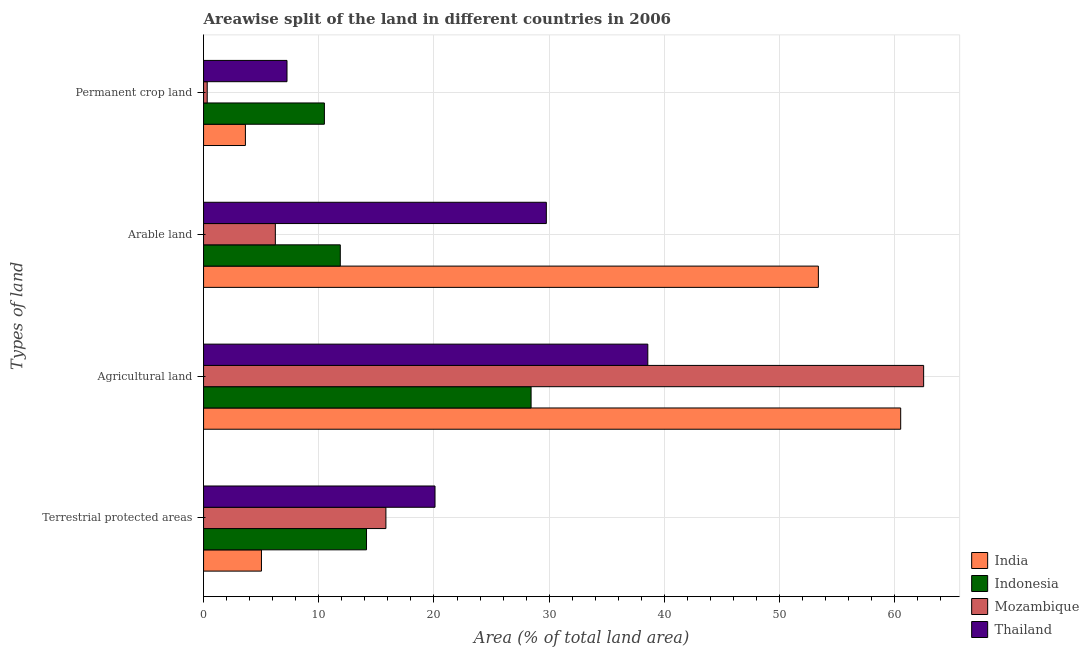How many different coloured bars are there?
Ensure brevity in your answer.  4. How many groups of bars are there?
Provide a short and direct response. 4. Are the number of bars per tick equal to the number of legend labels?
Give a very brief answer. Yes. How many bars are there on the 3rd tick from the bottom?
Provide a succinct answer. 4. What is the label of the 1st group of bars from the top?
Give a very brief answer. Permanent crop land. What is the percentage of area under permanent crop land in Mozambique?
Provide a short and direct response. 0.32. Across all countries, what is the maximum percentage of area under arable land?
Make the answer very short. 53.36. Across all countries, what is the minimum percentage of area under permanent crop land?
Ensure brevity in your answer.  0.32. In which country was the percentage of land under terrestrial protection maximum?
Your answer should be very brief. Thailand. In which country was the percentage of area under permanent crop land minimum?
Offer a terse response. Mozambique. What is the total percentage of area under permanent crop land in the graph?
Ensure brevity in your answer.  21.68. What is the difference between the percentage of area under agricultural land in India and that in Indonesia?
Give a very brief answer. 32.08. What is the difference between the percentage of land under terrestrial protection in Mozambique and the percentage of area under permanent crop land in India?
Ensure brevity in your answer.  12.19. What is the average percentage of area under permanent crop land per country?
Offer a very short reply. 5.42. What is the difference between the percentage of area under arable land and percentage of land under terrestrial protection in Indonesia?
Your response must be concise. -2.28. In how many countries, is the percentage of land under terrestrial protection greater than 30 %?
Your answer should be very brief. 0. What is the ratio of the percentage of land under terrestrial protection in India to that in Indonesia?
Ensure brevity in your answer.  0.36. Is the percentage of area under permanent crop land in Thailand less than that in Mozambique?
Provide a short and direct response. No. Is the difference between the percentage of area under arable land in Indonesia and Mozambique greater than the difference between the percentage of land under terrestrial protection in Indonesia and Mozambique?
Offer a terse response. Yes. What is the difference between the highest and the second highest percentage of area under agricultural land?
Provide a short and direct response. 1.99. What is the difference between the highest and the lowest percentage of area under arable land?
Offer a very short reply. 47.13. Is the sum of the percentage of area under arable land in Indonesia and India greater than the maximum percentage of area under agricultural land across all countries?
Give a very brief answer. Yes. What does the 2nd bar from the top in Permanent crop land represents?
Offer a very short reply. Mozambique. Are all the bars in the graph horizontal?
Ensure brevity in your answer.  Yes. What is the difference between two consecutive major ticks on the X-axis?
Keep it short and to the point. 10. Are the values on the major ticks of X-axis written in scientific E-notation?
Provide a succinct answer. No. Does the graph contain grids?
Your answer should be very brief. Yes. Where does the legend appear in the graph?
Offer a terse response. Bottom right. What is the title of the graph?
Give a very brief answer. Areawise split of the land in different countries in 2006. Does "Euro area" appear as one of the legend labels in the graph?
Provide a succinct answer. No. What is the label or title of the X-axis?
Keep it short and to the point. Area (% of total land area). What is the label or title of the Y-axis?
Your answer should be very brief. Types of land. What is the Area (% of total land area) in India in Terrestrial protected areas?
Your response must be concise. 5.03. What is the Area (% of total land area) in Indonesia in Terrestrial protected areas?
Keep it short and to the point. 14.14. What is the Area (% of total land area) of Mozambique in Terrestrial protected areas?
Give a very brief answer. 15.83. What is the Area (% of total land area) of Thailand in Terrestrial protected areas?
Provide a short and direct response. 20.09. What is the Area (% of total land area) of India in Agricultural land?
Offer a very short reply. 60.51. What is the Area (% of total land area) of Indonesia in Agricultural land?
Ensure brevity in your answer.  28.43. What is the Area (% of total land area) in Mozambique in Agricultural land?
Provide a succinct answer. 62.5. What is the Area (% of total land area) of Thailand in Agricultural land?
Your answer should be compact. 38.56. What is the Area (% of total land area) in India in Arable land?
Give a very brief answer. 53.36. What is the Area (% of total land area) in Indonesia in Arable land?
Offer a terse response. 11.87. What is the Area (% of total land area) in Mozambique in Arable land?
Your answer should be compact. 6.23. What is the Area (% of total land area) of Thailand in Arable land?
Give a very brief answer. 29.75. What is the Area (% of total land area) of India in Permanent crop land?
Provide a short and direct response. 3.63. What is the Area (% of total land area) of Indonesia in Permanent crop land?
Give a very brief answer. 10.49. What is the Area (% of total land area) in Mozambique in Permanent crop land?
Your answer should be very brief. 0.32. What is the Area (% of total land area) in Thailand in Permanent crop land?
Offer a terse response. 7.24. Across all Types of land, what is the maximum Area (% of total land area) of India?
Your answer should be compact. 60.51. Across all Types of land, what is the maximum Area (% of total land area) of Indonesia?
Your answer should be compact. 28.43. Across all Types of land, what is the maximum Area (% of total land area) in Mozambique?
Your response must be concise. 62.5. Across all Types of land, what is the maximum Area (% of total land area) of Thailand?
Offer a terse response. 38.56. Across all Types of land, what is the minimum Area (% of total land area) in India?
Your response must be concise. 3.63. Across all Types of land, what is the minimum Area (% of total land area) in Indonesia?
Your response must be concise. 10.49. Across all Types of land, what is the minimum Area (% of total land area) in Mozambique?
Your response must be concise. 0.32. Across all Types of land, what is the minimum Area (% of total land area) of Thailand?
Give a very brief answer. 7.24. What is the total Area (% of total land area) of India in the graph?
Your response must be concise. 122.53. What is the total Area (% of total land area) in Indonesia in the graph?
Your answer should be compact. 64.93. What is the total Area (% of total land area) of Mozambique in the graph?
Your response must be concise. 84.88. What is the total Area (% of total land area) of Thailand in the graph?
Provide a short and direct response. 95.64. What is the difference between the Area (% of total land area) of India in Terrestrial protected areas and that in Agricultural land?
Offer a very short reply. -55.48. What is the difference between the Area (% of total land area) of Indonesia in Terrestrial protected areas and that in Agricultural land?
Make the answer very short. -14.28. What is the difference between the Area (% of total land area) in Mozambique in Terrestrial protected areas and that in Agricultural land?
Give a very brief answer. -46.67. What is the difference between the Area (% of total land area) in Thailand in Terrestrial protected areas and that in Agricultural land?
Your response must be concise. -18.47. What is the difference between the Area (% of total land area) of India in Terrestrial protected areas and that in Arable land?
Your response must be concise. -48.34. What is the difference between the Area (% of total land area) in Indonesia in Terrestrial protected areas and that in Arable land?
Provide a short and direct response. 2.28. What is the difference between the Area (% of total land area) of Mozambique in Terrestrial protected areas and that in Arable land?
Your answer should be very brief. 9.6. What is the difference between the Area (% of total land area) of Thailand in Terrestrial protected areas and that in Arable land?
Offer a very short reply. -9.66. What is the difference between the Area (% of total land area) of India in Terrestrial protected areas and that in Permanent crop land?
Your response must be concise. 1.39. What is the difference between the Area (% of total land area) in Indonesia in Terrestrial protected areas and that in Permanent crop land?
Give a very brief answer. 3.66. What is the difference between the Area (% of total land area) of Mozambique in Terrestrial protected areas and that in Permanent crop land?
Your answer should be very brief. 15.51. What is the difference between the Area (% of total land area) of Thailand in Terrestrial protected areas and that in Permanent crop land?
Your answer should be compact. 12.85. What is the difference between the Area (% of total land area) of India in Agricultural land and that in Arable land?
Your response must be concise. 7.15. What is the difference between the Area (% of total land area) of Indonesia in Agricultural land and that in Arable land?
Offer a terse response. 16.56. What is the difference between the Area (% of total land area) of Mozambique in Agricultural land and that in Arable land?
Your answer should be very brief. 56.27. What is the difference between the Area (% of total land area) in Thailand in Agricultural land and that in Arable land?
Your answer should be compact. 8.81. What is the difference between the Area (% of total land area) in India in Agricultural land and that in Permanent crop land?
Ensure brevity in your answer.  56.88. What is the difference between the Area (% of total land area) of Indonesia in Agricultural land and that in Permanent crop land?
Keep it short and to the point. 17.94. What is the difference between the Area (% of total land area) of Mozambique in Agricultural land and that in Permanent crop land?
Your answer should be compact. 62.18. What is the difference between the Area (% of total land area) of Thailand in Agricultural land and that in Permanent crop land?
Keep it short and to the point. 31.32. What is the difference between the Area (% of total land area) in India in Arable land and that in Permanent crop land?
Your response must be concise. 49.73. What is the difference between the Area (% of total land area) of Indonesia in Arable land and that in Permanent crop land?
Your answer should be compact. 1.38. What is the difference between the Area (% of total land area) of Mozambique in Arable land and that in Permanent crop land?
Offer a terse response. 5.91. What is the difference between the Area (% of total land area) in Thailand in Arable land and that in Permanent crop land?
Give a very brief answer. 22.51. What is the difference between the Area (% of total land area) in India in Terrestrial protected areas and the Area (% of total land area) in Indonesia in Agricultural land?
Give a very brief answer. -23.4. What is the difference between the Area (% of total land area) in India in Terrestrial protected areas and the Area (% of total land area) in Mozambique in Agricultural land?
Your answer should be compact. -57.48. What is the difference between the Area (% of total land area) in India in Terrestrial protected areas and the Area (% of total land area) in Thailand in Agricultural land?
Offer a very short reply. -33.54. What is the difference between the Area (% of total land area) of Indonesia in Terrestrial protected areas and the Area (% of total land area) of Mozambique in Agricultural land?
Offer a very short reply. -48.36. What is the difference between the Area (% of total land area) of Indonesia in Terrestrial protected areas and the Area (% of total land area) of Thailand in Agricultural land?
Offer a very short reply. -24.42. What is the difference between the Area (% of total land area) in Mozambique in Terrestrial protected areas and the Area (% of total land area) in Thailand in Agricultural land?
Keep it short and to the point. -22.73. What is the difference between the Area (% of total land area) of India in Terrestrial protected areas and the Area (% of total land area) of Indonesia in Arable land?
Make the answer very short. -6.84. What is the difference between the Area (% of total land area) of India in Terrestrial protected areas and the Area (% of total land area) of Mozambique in Arable land?
Make the answer very short. -1.21. What is the difference between the Area (% of total land area) of India in Terrestrial protected areas and the Area (% of total land area) of Thailand in Arable land?
Offer a terse response. -24.73. What is the difference between the Area (% of total land area) in Indonesia in Terrestrial protected areas and the Area (% of total land area) in Mozambique in Arable land?
Make the answer very short. 7.91. What is the difference between the Area (% of total land area) of Indonesia in Terrestrial protected areas and the Area (% of total land area) of Thailand in Arable land?
Offer a terse response. -15.61. What is the difference between the Area (% of total land area) in Mozambique in Terrestrial protected areas and the Area (% of total land area) in Thailand in Arable land?
Provide a short and direct response. -13.92. What is the difference between the Area (% of total land area) of India in Terrestrial protected areas and the Area (% of total land area) of Indonesia in Permanent crop land?
Keep it short and to the point. -5.46. What is the difference between the Area (% of total land area) in India in Terrestrial protected areas and the Area (% of total land area) in Mozambique in Permanent crop land?
Provide a succinct answer. 4.71. What is the difference between the Area (% of total land area) of India in Terrestrial protected areas and the Area (% of total land area) of Thailand in Permanent crop land?
Provide a short and direct response. -2.22. What is the difference between the Area (% of total land area) of Indonesia in Terrestrial protected areas and the Area (% of total land area) of Mozambique in Permanent crop land?
Provide a short and direct response. 13.83. What is the difference between the Area (% of total land area) of Indonesia in Terrestrial protected areas and the Area (% of total land area) of Thailand in Permanent crop land?
Provide a short and direct response. 6.9. What is the difference between the Area (% of total land area) of Mozambique in Terrestrial protected areas and the Area (% of total land area) of Thailand in Permanent crop land?
Give a very brief answer. 8.59. What is the difference between the Area (% of total land area) of India in Agricultural land and the Area (% of total land area) of Indonesia in Arable land?
Provide a short and direct response. 48.64. What is the difference between the Area (% of total land area) in India in Agricultural land and the Area (% of total land area) in Mozambique in Arable land?
Give a very brief answer. 54.28. What is the difference between the Area (% of total land area) in India in Agricultural land and the Area (% of total land area) in Thailand in Arable land?
Provide a short and direct response. 30.76. What is the difference between the Area (% of total land area) of Indonesia in Agricultural land and the Area (% of total land area) of Mozambique in Arable land?
Your answer should be very brief. 22.2. What is the difference between the Area (% of total land area) in Indonesia in Agricultural land and the Area (% of total land area) in Thailand in Arable land?
Keep it short and to the point. -1.32. What is the difference between the Area (% of total land area) in Mozambique in Agricultural land and the Area (% of total land area) in Thailand in Arable land?
Offer a terse response. 32.75. What is the difference between the Area (% of total land area) of India in Agricultural land and the Area (% of total land area) of Indonesia in Permanent crop land?
Keep it short and to the point. 50.02. What is the difference between the Area (% of total land area) of India in Agricultural land and the Area (% of total land area) of Mozambique in Permanent crop land?
Your response must be concise. 60.19. What is the difference between the Area (% of total land area) of India in Agricultural land and the Area (% of total land area) of Thailand in Permanent crop land?
Offer a terse response. 53.27. What is the difference between the Area (% of total land area) of Indonesia in Agricultural land and the Area (% of total land area) of Mozambique in Permanent crop land?
Provide a short and direct response. 28.11. What is the difference between the Area (% of total land area) in Indonesia in Agricultural land and the Area (% of total land area) in Thailand in Permanent crop land?
Offer a very short reply. 21.19. What is the difference between the Area (% of total land area) of Mozambique in Agricultural land and the Area (% of total land area) of Thailand in Permanent crop land?
Provide a succinct answer. 55.26. What is the difference between the Area (% of total land area) in India in Arable land and the Area (% of total land area) in Indonesia in Permanent crop land?
Your response must be concise. 42.88. What is the difference between the Area (% of total land area) of India in Arable land and the Area (% of total land area) of Mozambique in Permanent crop land?
Provide a succinct answer. 53.05. What is the difference between the Area (% of total land area) in India in Arable land and the Area (% of total land area) in Thailand in Permanent crop land?
Provide a succinct answer. 46.12. What is the difference between the Area (% of total land area) of Indonesia in Arable land and the Area (% of total land area) of Mozambique in Permanent crop land?
Offer a very short reply. 11.55. What is the difference between the Area (% of total land area) of Indonesia in Arable land and the Area (% of total land area) of Thailand in Permanent crop land?
Offer a terse response. 4.63. What is the difference between the Area (% of total land area) in Mozambique in Arable land and the Area (% of total land area) in Thailand in Permanent crop land?
Provide a short and direct response. -1.01. What is the average Area (% of total land area) in India per Types of land?
Your answer should be compact. 30.63. What is the average Area (% of total land area) of Indonesia per Types of land?
Offer a very short reply. 16.23. What is the average Area (% of total land area) in Mozambique per Types of land?
Offer a very short reply. 21.22. What is the average Area (% of total land area) of Thailand per Types of land?
Give a very brief answer. 23.91. What is the difference between the Area (% of total land area) of India and Area (% of total land area) of Indonesia in Terrestrial protected areas?
Ensure brevity in your answer.  -9.12. What is the difference between the Area (% of total land area) in India and Area (% of total land area) in Mozambique in Terrestrial protected areas?
Make the answer very short. -10.8. What is the difference between the Area (% of total land area) in India and Area (% of total land area) in Thailand in Terrestrial protected areas?
Offer a terse response. -15.07. What is the difference between the Area (% of total land area) in Indonesia and Area (% of total land area) in Mozambique in Terrestrial protected areas?
Make the answer very short. -1.68. What is the difference between the Area (% of total land area) of Indonesia and Area (% of total land area) of Thailand in Terrestrial protected areas?
Offer a very short reply. -5.95. What is the difference between the Area (% of total land area) in Mozambique and Area (% of total land area) in Thailand in Terrestrial protected areas?
Make the answer very short. -4.26. What is the difference between the Area (% of total land area) of India and Area (% of total land area) of Indonesia in Agricultural land?
Your answer should be very brief. 32.08. What is the difference between the Area (% of total land area) of India and Area (% of total land area) of Mozambique in Agricultural land?
Give a very brief answer. -1.99. What is the difference between the Area (% of total land area) in India and Area (% of total land area) in Thailand in Agricultural land?
Ensure brevity in your answer.  21.95. What is the difference between the Area (% of total land area) of Indonesia and Area (% of total land area) of Mozambique in Agricultural land?
Offer a very short reply. -34.07. What is the difference between the Area (% of total land area) of Indonesia and Area (% of total land area) of Thailand in Agricultural land?
Keep it short and to the point. -10.13. What is the difference between the Area (% of total land area) in Mozambique and Area (% of total land area) in Thailand in Agricultural land?
Provide a succinct answer. 23.94. What is the difference between the Area (% of total land area) of India and Area (% of total land area) of Indonesia in Arable land?
Give a very brief answer. 41.5. What is the difference between the Area (% of total land area) of India and Area (% of total land area) of Mozambique in Arable land?
Give a very brief answer. 47.13. What is the difference between the Area (% of total land area) in India and Area (% of total land area) in Thailand in Arable land?
Keep it short and to the point. 23.61. What is the difference between the Area (% of total land area) in Indonesia and Area (% of total land area) in Mozambique in Arable land?
Provide a short and direct response. 5.64. What is the difference between the Area (% of total land area) in Indonesia and Area (% of total land area) in Thailand in Arable land?
Keep it short and to the point. -17.88. What is the difference between the Area (% of total land area) in Mozambique and Area (% of total land area) in Thailand in Arable land?
Your answer should be compact. -23.52. What is the difference between the Area (% of total land area) of India and Area (% of total land area) of Indonesia in Permanent crop land?
Offer a very short reply. -6.86. What is the difference between the Area (% of total land area) of India and Area (% of total land area) of Mozambique in Permanent crop land?
Provide a short and direct response. 3.31. What is the difference between the Area (% of total land area) of India and Area (% of total land area) of Thailand in Permanent crop land?
Give a very brief answer. -3.61. What is the difference between the Area (% of total land area) of Indonesia and Area (% of total land area) of Mozambique in Permanent crop land?
Offer a terse response. 10.17. What is the difference between the Area (% of total land area) of Indonesia and Area (% of total land area) of Thailand in Permanent crop land?
Your answer should be compact. 3.25. What is the difference between the Area (% of total land area) of Mozambique and Area (% of total land area) of Thailand in Permanent crop land?
Provide a short and direct response. -6.92. What is the ratio of the Area (% of total land area) of India in Terrestrial protected areas to that in Agricultural land?
Make the answer very short. 0.08. What is the ratio of the Area (% of total land area) in Indonesia in Terrestrial protected areas to that in Agricultural land?
Your answer should be very brief. 0.5. What is the ratio of the Area (% of total land area) of Mozambique in Terrestrial protected areas to that in Agricultural land?
Keep it short and to the point. 0.25. What is the ratio of the Area (% of total land area) of Thailand in Terrestrial protected areas to that in Agricultural land?
Offer a terse response. 0.52. What is the ratio of the Area (% of total land area) in India in Terrestrial protected areas to that in Arable land?
Keep it short and to the point. 0.09. What is the ratio of the Area (% of total land area) of Indonesia in Terrestrial protected areas to that in Arable land?
Keep it short and to the point. 1.19. What is the ratio of the Area (% of total land area) of Mozambique in Terrestrial protected areas to that in Arable land?
Offer a very short reply. 2.54. What is the ratio of the Area (% of total land area) in Thailand in Terrestrial protected areas to that in Arable land?
Provide a short and direct response. 0.68. What is the ratio of the Area (% of total land area) of India in Terrestrial protected areas to that in Permanent crop land?
Keep it short and to the point. 1.38. What is the ratio of the Area (% of total land area) in Indonesia in Terrestrial protected areas to that in Permanent crop land?
Your answer should be compact. 1.35. What is the ratio of the Area (% of total land area) of Mozambique in Terrestrial protected areas to that in Permanent crop land?
Give a very brief answer. 49.79. What is the ratio of the Area (% of total land area) in Thailand in Terrestrial protected areas to that in Permanent crop land?
Offer a very short reply. 2.77. What is the ratio of the Area (% of total land area) in India in Agricultural land to that in Arable land?
Give a very brief answer. 1.13. What is the ratio of the Area (% of total land area) of Indonesia in Agricultural land to that in Arable land?
Your answer should be compact. 2.4. What is the ratio of the Area (% of total land area) in Mozambique in Agricultural land to that in Arable land?
Make the answer very short. 10.03. What is the ratio of the Area (% of total land area) in Thailand in Agricultural land to that in Arable land?
Provide a short and direct response. 1.3. What is the ratio of the Area (% of total land area) of India in Agricultural land to that in Permanent crop land?
Provide a succinct answer. 16.66. What is the ratio of the Area (% of total land area) of Indonesia in Agricultural land to that in Permanent crop land?
Your answer should be very brief. 2.71. What is the ratio of the Area (% of total land area) in Mozambique in Agricultural land to that in Permanent crop land?
Provide a succinct answer. 196.6. What is the ratio of the Area (% of total land area) in Thailand in Agricultural land to that in Permanent crop land?
Ensure brevity in your answer.  5.32. What is the ratio of the Area (% of total land area) of India in Arable land to that in Permanent crop land?
Give a very brief answer. 14.69. What is the ratio of the Area (% of total land area) of Indonesia in Arable land to that in Permanent crop land?
Keep it short and to the point. 1.13. What is the ratio of the Area (% of total land area) in Mozambique in Arable land to that in Permanent crop land?
Give a very brief answer. 19.6. What is the ratio of the Area (% of total land area) in Thailand in Arable land to that in Permanent crop land?
Give a very brief answer. 4.11. What is the difference between the highest and the second highest Area (% of total land area) in India?
Provide a succinct answer. 7.15. What is the difference between the highest and the second highest Area (% of total land area) of Indonesia?
Your answer should be very brief. 14.28. What is the difference between the highest and the second highest Area (% of total land area) of Mozambique?
Give a very brief answer. 46.67. What is the difference between the highest and the second highest Area (% of total land area) in Thailand?
Your response must be concise. 8.81. What is the difference between the highest and the lowest Area (% of total land area) in India?
Your response must be concise. 56.88. What is the difference between the highest and the lowest Area (% of total land area) in Indonesia?
Give a very brief answer. 17.94. What is the difference between the highest and the lowest Area (% of total land area) in Mozambique?
Provide a short and direct response. 62.18. What is the difference between the highest and the lowest Area (% of total land area) of Thailand?
Provide a short and direct response. 31.32. 